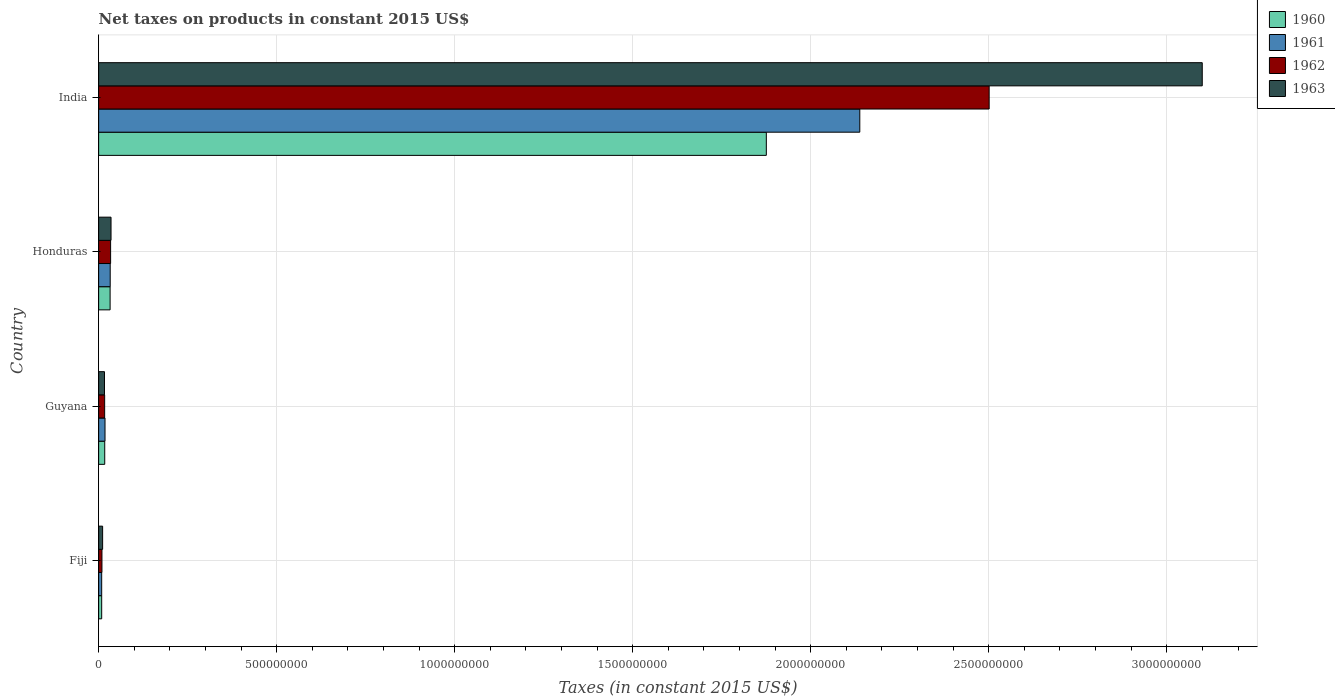How many different coloured bars are there?
Offer a very short reply. 4. How many groups of bars are there?
Ensure brevity in your answer.  4. Are the number of bars per tick equal to the number of legend labels?
Your response must be concise. Yes. How many bars are there on the 1st tick from the top?
Offer a very short reply. 4. What is the label of the 2nd group of bars from the top?
Offer a very short reply. Honduras. What is the net taxes on products in 1961 in Guyana?
Your answer should be very brief. 1.79e+07. Across all countries, what is the maximum net taxes on products in 1962?
Make the answer very short. 2.50e+09. Across all countries, what is the minimum net taxes on products in 1960?
Ensure brevity in your answer.  8.56e+06. In which country was the net taxes on products in 1963 maximum?
Your answer should be very brief. India. In which country was the net taxes on products in 1961 minimum?
Your answer should be very brief. Fiji. What is the total net taxes on products in 1961 in the graph?
Keep it short and to the point. 2.20e+09. What is the difference between the net taxes on products in 1961 in Guyana and that in India?
Ensure brevity in your answer.  -2.12e+09. What is the difference between the net taxes on products in 1962 in India and the net taxes on products in 1960 in Honduras?
Make the answer very short. 2.47e+09. What is the average net taxes on products in 1963 per country?
Give a very brief answer. 7.91e+08. What is the difference between the net taxes on products in 1960 and net taxes on products in 1962 in Fiji?
Offer a very short reply. -7.56e+05. What is the ratio of the net taxes on products in 1963 in Fiji to that in Guyana?
Keep it short and to the point. 0.68. Is the net taxes on products in 1960 in Fiji less than that in Guyana?
Give a very brief answer. Yes. Is the difference between the net taxes on products in 1960 in Fiji and Honduras greater than the difference between the net taxes on products in 1962 in Fiji and Honduras?
Your response must be concise. Yes. What is the difference between the highest and the second highest net taxes on products in 1960?
Provide a succinct answer. 1.84e+09. What is the difference between the highest and the lowest net taxes on products in 1963?
Your response must be concise. 3.09e+09. In how many countries, is the net taxes on products in 1960 greater than the average net taxes on products in 1960 taken over all countries?
Offer a very short reply. 1. Is the sum of the net taxes on products in 1961 in Fiji and India greater than the maximum net taxes on products in 1962 across all countries?
Keep it short and to the point. No. Is it the case that in every country, the sum of the net taxes on products in 1960 and net taxes on products in 1961 is greater than the net taxes on products in 1963?
Your response must be concise. Yes. How many countries are there in the graph?
Keep it short and to the point. 4. What is the difference between two consecutive major ticks on the X-axis?
Keep it short and to the point. 5.00e+08. Where does the legend appear in the graph?
Provide a short and direct response. Top right. How are the legend labels stacked?
Give a very brief answer. Vertical. What is the title of the graph?
Give a very brief answer. Net taxes on products in constant 2015 US$. Does "1977" appear as one of the legend labels in the graph?
Your answer should be compact. No. What is the label or title of the X-axis?
Offer a terse response. Taxes (in constant 2015 US$). What is the label or title of the Y-axis?
Your response must be concise. Country. What is the Taxes (in constant 2015 US$) in 1960 in Fiji?
Make the answer very short. 8.56e+06. What is the Taxes (in constant 2015 US$) of 1961 in Fiji?
Provide a succinct answer. 8.56e+06. What is the Taxes (in constant 2015 US$) in 1962 in Fiji?
Make the answer very short. 9.32e+06. What is the Taxes (in constant 2015 US$) of 1963 in Fiji?
Your answer should be compact. 1.12e+07. What is the Taxes (in constant 2015 US$) in 1960 in Guyana?
Provide a short and direct response. 1.71e+07. What is the Taxes (in constant 2015 US$) in 1961 in Guyana?
Keep it short and to the point. 1.79e+07. What is the Taxes (in constant 2015 US$) in 1962 in Guyana?
Give a very brief answer. 1.69e+07. What is the Taxes (in constant 2015 US$) in 1963 in Guyana?
Ensure brevity in your answer.  1.64e+07. What is the Taxes (in constant 2015 US$) of 1960 in Honduras?
Give a very brief answer. 3.22e+07. What is the Taxes (in constant 2015 US$) of 1961 in Honduras?
Your response must be concise. 3.25e+07. What is the Taxes (in constant 2015 US$) in 1962 in Honduras?
Ensure brevity in your answer.  3.36e+07. What is the Taxes (in constant 2015 US$) in 1963 in Honduras?
Offer a very short reply. 3.48e+07. What is the Taxes (in constant 2015 US$) of 1960 in India?
Make the answer very short. 1.88e+09. What is the Taxes (in constant 2015 US$) in 1961 in India?
Your response must be concise. 2.14e+09. What is the Taxes (in constant 2015 US$) in 1962 in India?
Make the answer very short. 2.50e+09. What is the Taxes (in constant 2015 US$) of 1963 in India?
Your answer should be very brief. 3.10e+09. Across all countries, what is the maximum Taxes (in constant 2015 US$) in 1960?
Provide a succinct answer. 1.88e+09. Across all countries, what is the maximum Taxes (in constant 2015 US$) of 1961?
Your answer should be very brief. 2.14e+09. Across all countries, what is the maximum Taxes (in constant 2015 US$) in 1962?
Make the answer very short. 2.50e+09. Across all countries, what is the maximum Taxes (in constant 2015 US$) in 1963?
Provide a short and direct response. 3.10e+09. Across all countries, what is the minimum Taxes (in constant 2015 US$) in 1960?
Your response must be concise. 8.56e+06. Across all countries, what is the minimum Taxes (in constant 2015 US$) of 1961?
Your answer should be compact. 8.56e+06. Across all countries, what is the minimum Taxes (in constant 2015 US$) of 1962?
Offer a very short reply. 9.32e+06. Across all countries, what is the minimum Taxes (in constant 2015 US$) in 1963?
Your answer should be very brief. 1.12e+07. What is the total Taxes (in constant 2015 US$) of 1960 in the graph?
Offer a very short reply. 1.93e+09. What is the total Taxes (in constant 2015 US$) in 1961 in the graph?
Your answer should be very brief. 2.20e+09. What is the total Taxes (in constant 2015 US$) in 1962 in the graph?
Give a very brief answer. 2.56e+09. What is the total Taxes (in constant 2015 US$) in 1963 in the graph?
Your response must be concise. 3.16e+09. What is the difference between the Taxes (in constant 2015 US$) in 1960 in Fiji and that in Guyana?
Provide a succinct answer. -8.59e+06. What is the difference between the Taxes (in constant 2015 US$) in 1961 in Fiji and that in Guyana?
Provide a succinct answer. -9.34e+06. What is the difference between the Taxes (in constant 2015 US$) of 1962 in Fiji and that in Guyana?
Your answer should be compact. -7.60e+06. What is the difference between the Taxes (in constant 2015 US$) in 1963 in Fiji and that in Guyana?
Provide a short and direct response. -5.24e+06. What is the difference between the Taxes (in constant 2015 US$) in 1960 in Fiji and that in Honduras?
Provide a succinct answer. -2.37e+07. What is the difference between the Taxes (in constant 2015 US$) of 1961 in Fiji and that in Honduras?
Keep it short and to the point. -2.39e+07. What is the difference between the Taxes (in constant 2015 US$) of 1962 in Fiji and that in Honduras?
Keep it short and to the point. -2.43e+07. What is the difference between the Taxes (in constant 2015 US$) in 1963 in Fiji and that in Honduras?
Ensure brevity in your answer.  -2.36e+07. What is the difference between the Taxes (in constant 2015 US$) of 1960 in Fiji and that in India?
Provide a short and direct response. -1.87e+09. What is the difference between the Taxes (in constant 2015 US$) in 1961 in Fiji and that in India?
Offer a terse response. -2.13e+09. What is the difference between the Taxes (in constant 2015 US$) of 1962 in Fiji and that in India?
Your answer should be very brief. -2.49e+09. What is the difference between the Taxes (in constant 2015 US$) in 1963 in Fiji and that in India?
Offer a terse response. -3.09e+09. What is the difference between the Taxes (in constant 2015 US$) of 1960 in Guyana and that in Honduras?
Offer a terse response. -1.51e+07. What is the difference between the Taxes (in constant 2015 US$) of 1961 in Guyana and that in Honduras?
Ensure brevity in your answer.  -1.46e+07. What is the difference between the Taxes (in constant 2015 US$) of 1962 in Guyana and that in Honduras?
Provide a succinct answer. -1.67e+07. What is the difference between the Taxes (in constant 2015 US$) of 1963 in Guyana and that in Honduras?
Give a very brief answer. -1.84e+07. What is the difference between the Taxes (in constant 2015 US$) of 1960 in Guyana and that in India?
Keep it short and to the point. -1.86e+09. What is the difference between the Taxes (in constant 2015 US$) in 1961 in Guyana and that in India?
Offer a terse response. -2.12e+09. What is the difference between the Taxes (in constant 2015 US$) of 1962 in Guyana and that in India?
Keep it short and to the point. -2.48e+09. What is the difference between the Taxes (in constant 2015 US$) in 1963 in Guyana and that in India?
Your answer should be very brief. -3.08e+09. What is the difference between the Taxes (in constant 2015 US$) of 1960 in Honduras and that in India?
Your answer should be compact. -1.84e+09. What is the difference between the Taxes (in constant 2015 US$) in 1961 in Honduras and that in India?
Provide a succinct answer. -2.11e+09. What is the difference between the Taxes (in constant 2015 US$) of 1962 in Honduras and that in India?
Keep it short and to the point. -2.47e+09. What is the difference between the Taxes (in constant 2015 US$) of 1963 in Honduras and that in India?
Your answer should be compact. -3.06e+09. What is the difference between the Taxes (in constant 2015 US$) in 1960 in Fiji and the Taxes (in constant 2015 US$) in 1961 in Guyana?
Your response must be concise. -9.34e+06. What is the difference between the Taxes (in constant 2015 US$) of 1960 in Fiji and the Taxes (in constant 2015 US$) of 1962 in Guyana?
Give a very brief answer. -8.35e+06. What is the difference between the Taxes (in constant 2015 US$) of 1960 in Fiji and the Taxes (in constant 2015 US$) of 1963 in Guyana?
Your response must be concise. -7.89e+06. What is the difference between the Taxes (in constant 2015 US$) of 1961 in Fiji and the Taxes (in constant 2015 US$) of 1962 in Guyana?
Provide a succinct answer. -8.35e+06. What is the difference between the Taxes (in constant 2015 US$) of 1961 in Fiji and the Taxes (in constant 2015 US$) of 1963 in Guyana?
Your response must be concise. -7.89e+06. What is the difference between the Taxes (in constant 2015 US$) of 1962 in Fiji and the Taxes (in constant 2015 US$) of 1963 in Guyana?
Provide a short and direct response. -7.13e+06. What is the difference between the Taxes (in constant 2015 US$) of 1960 in Fiji and the Taxes (in constant 2015 US$) of 1961 in Honduras?
Give a very brief answer. -2.39e+07. What is the difference between the Taxes (in constant 2015 US$) in 1960 in Fiji and the Taxes (in constant 2015 US$) in 1962 in Honduras?
Provide a succinct answer. -2.51e+07. What is the difference between the Taxes (in constant 2015 US$) of 1960 in Fiji and the Taxes (in constant 2015 US$) of 1963 in Honduras?
Offer a very short reply. -2.62e+07. What is the difference between the Taxes (in constant 2015 US$) in 1961 in Fiji and the Taxes (in constant 2015 US$) in 1962 in Honduras?
Your answer should be very brief. -2.51e+07. What is the difference between the Taxes (in constant 2015 US$) of 1961 in Fiji and the Taxes (in constant 2015 US$) of 1963 in Honduras?
Give a very brief answer. -2.62e+07. What is the difference between the Taxes (in constant 2015 US$) of 1962 in Fiji and the Taxes (in constant 2015 US$) of 1963 in Honduras?
Offer a terse response. -2.55e+07. What is the difference between the Taxes (in constant 2015 US$) of 1960 in Fiji and the Taxes (in constant 2015 US$) of 1961 in India?
Ensure brevity in your answer.  -2.13e+09. What is the difference between the Taxes (in constant 2015 US$) in 1960 in Fiji and the Taxes (in constant 2015 US$) in 1962 in India?
Offer a terse response. -2.49e+09. What is the difference between the Taxes (in constant 2015 US$) in 1960 in Fiji and the Taxes (in constant 2015 US$) in 1963 in India?
Your response must be concise. -3.09e+09. What is the difference between the Taxes (in constant 2015 US$) of 1961 in Fiji and the Taxes (in constant 2015 US$) of 1962 in India?
Provide a succinct answer. -2.49e+09. What is the difference between the Taxes (in constant 2015 US$) in 1961 in Fiji and the Taxes (in constant 2015 US$) in 1963 in India?
Make the answer very short. -3.09e+09. What is the difference between the Taxes (in constant 2015 US$) in 1962 in Fiji and the Taxes (in constant 2015 US$) in 1963 in India?
Provide a succinct answer. -3.09e+09. What is the difference between the Taxes (in constant 2015 US$) in 1960 in Guyana and the Taxes (in constant 2015 US$) in 1961 in Honduras?
Your response must be concise. -1.54e+07. What is the difference between the Taxes (in constant 2015 US$) in 1960 in Guyana and the Taxes (in constant 2015 US$) in 1962 in Honduras?
Keep it short and to the point. -1.65e+07. What is the difference between the Taxes (in constant 2015 US$) in 1960 in Guyana and the Taxes (in constant 2015 US$) in 1963 in Honduras?
Provide a succinct answer. -1.77e+07. What is the difference between the Taxes (in constant 2015 US$) of 1961 in Guyana and the Taxes (in constant 2015 US$) of 1962 in Honduras?
Your answer should be very brief. -1.57e+07. What is the difference between the Taxes (in constant 2015 US$) of 1961 in Guyana and the Taxes (in constant 2015 US$) of 1963 in Honduras?
Keep it short and to the point. -1.69e+07. What is the difference between the Taxes (in constant 2015 US$) of 1962 in Guyana and the Taxes (in constant 2015 US$) of 1963 in Honduras?
Your answer should be compact. -1.79e+07. What is the difference between the Taxes (in constant 2015 US$) in 1960 in Guyana and the Taxes (in constant 2015 US$) in 1961 in India?
Make the answer very short. -2.12e+09. What is the difference between the Taxes (in constant 2015 US$) of 1960 in Guyana and the Taxes (in constant 2015 US$) of 1962 in India?
Give a very brief answer. -2.48e+09. What is the difference between the Taxes (in constant 2015 US$) in 1960 in Guyana and the Taxes (in constant 2015 US$) in 1963 in India?
Give a very brief answer. -3.08e+09. What is the difference between the Taxes (in constant 2015 US$) in 1961 in Guyana and the Taxes (in constant 2015 US$) in 1962 in India?
Your answer should be very brief. -2.48e+09. What is the difference between the Taxes (in constant 2015 US$) of 1961 in Guyana and the Taxes (in constant 2015 US$) of 1963 in India?
Provide a short and direct response. -3.08e+09. What is the difference between the Taxes (in constant 2015 US$) in 1962 in Guyana and the Taxes (in constant 2015 US$) in 1963 in India?
Offer a terse response. -3.08e+09. What is the difference between the Taxes (in constant 2015 US$) in 1960 in Honduras and the Taxes (in constant 2015 US$) in 1961 in India?
Offer a very short reply. -2.11e+09. What is the difference between the Taxes (in constant 2015 US$) of 1960 in Honduras and the Taxes (in constant 2015 US$) of 1962 in India?
Ensure brevity in your answer.  -2.47e+09. What is the difference between the Taxes (in constant 2015 US$) of 1960 in Honduras and the Taxes (in constant 2015 US$) of 1963 in India?
Keep it short and to the point. -3.07e+09. What is the difference between the Taxes (in constant 2015 US$) of 1961 in Honduras and the Taxes (in constant 2015 US$) of 1962 in India?
Your answer should be very brief. -2.47e+09. What is the difference between the Taxes (in constant 2015 US$) of 1961 in Honduras and the Taxes (in constant 2015 US$) of 1963 in India?
Keep it short and to the point. -3.07e+09. What is the difference between the Taxes (in constant 2015 US$) in 1962 in Honduras and the Taxes (in constant 2015 US$) in 1963 in India?
Your answer should be compact. -3.07e+09. What is the average Taxes (in constant 2015 US$) in 1960 per country?
Your answer should be very brief. 4.83e+08. What is the average Taxes (in constant 2015 US$) in 1961 per country?
Your answer should be very brief. 5.49e+08. What is the average Taxes (in constant 2015 US$) in 1962 per country?
Ensure brevity in your answer.  6.40e+08. What is the average Taxes (in constant 2015 US$) in 1963 per country?
Ensure brevity in your answer.  7.91e+08. What is the difference between the Taxes (in constant 2015 US$) in 1960 and Taxes (in constant 2015 US$) in 1961 in Fiji?
Keep it short and to the point. 0. What is the difference between the Taxes (in constant 2015 US$) of 1960 and Taxes (in constant 2015 US$) of 1962 in Fiji?
Your answer should be compact. -7.56e+05. What is the difference between the Taxes (in constant 2015 US$) of 1960 and Taxes (in constant 2015 US$) of 1963 in Fiji?
Your answer should be compact. -2.64e+06. What is the difference between the Taxes (in constant 2015 US$) of 1961 and Taxes (in constant 2015 US$) of 1962 in Fiji?
Keep it short and to the point. -7.56e+05. What is the difference between the Taxes (in constant 2015 US$) of 1961 and Taxes (in constant 2015 US$) of 1963 in Fiji?
Your answer should be compact. -2.64e+06. What is the difference between the Taxes (in constant 2015 US$) in 1962 and Taxes (in constant 2015 US$) in 1963 in Fiji?
Offer a terse response. -1.89e+06. What is the difference between the Taxes (in constant 2015 US$) in 1960 and Taxes (in constant 2015 US$) in 1961 in Guyana?
Give a very brief answer. -7.58e+05. What is the difference between the Taxes (in constant 2015 US$) of 1960 and Taxes (in constant 2015 US$) of 1962 in Guyana?
Provide a succinct answer. 2.33e+05. What is the difference between the Taxes (in constant 2015 US$) in 1960 and Taxes (in constant 2015 US$) in 1963 in Guyana?
Your answer should be compact. 7.00e+05. What is the difference between the Taxes (in constant 2015 US$) of 1961 and Taxes (in constant 2015 US$) of 1962 in Guyana?
Provide a short and direct response. 9.92e+05. What is the difference between the Taxes (in constant 2015 US$) of 1961 and Taxes (in constant 2015 US$) of 1963 in Guyana?
Provide a short and direct response. 1.46e+06. What is the difference between the Taxes (in constant 2015 US$) in 1962 and Taxes (in constant 2015 US$) in 1963 in Guyana?
Your response must be concise. 4.67e+05. What is the difference between the Taxes (in constant 2015 US$) in 1960 and Taxes (in constant 2015 US$) in 1961 in Honduras?
Provide a short and direct response. -2.50e+05. What is the difference between the Taxes (in constant 2015 US$) of 1960 and Taxes (in constant 2015 US$) of 1962 in Honduras?
Provide a short and direct response. -1.40e+06. What is the difference between the Taxes (in constant 2015 US$) of 1960 and Taxes (in constant 2015 US$) of 1963 in Honduras?
Provide a short and direct response. -2.55e+06. What is the difference between the Taxes (in constant 2015 US$) in 1961 and Taxes (in constant 2015 US$) in 1962 in Honduras?
Your answer should be very brief. -1.15e+06. What is the difference between the Taxes (in constant 2015 US$) in 1961 and Taxes (in constant 2015 US$) in 1963 in Honduras?
Keep it short and to the point. -2.30e+06. What is the difference between the Taxes (in constant 2015 US$) of 1962 and Taxes (in constant 2015 US$) of 1963 in Honduras?
Give a very brief answer. -1.15e+06. What is the difference between the Taxes (in constant 2015 US$) in 1960 and Taxes (in constant 2015 US$) in 1961 in India?
Your answer should be compact. -2.63e+08. What is the difference between the Taxes (in constant 2015 US$) in 1960 and Taxes (in constant 2015 US$) in 1962 in India?
Give a very brief answer. -6.26e+08. What is the difference between the Taxes (in constant 2015 US$) of 1960 and Taxes (in constant 2015 US$) of 1963 in India?
Your answer should be compact. -1.22e+09. What is the difference between the Taxes (in constant 2015 US$) of 1961 and Taxes (in constant 2015 US$) of 1962 in India?
Offer a terse response. -3.63e+08. What is the difference between the Taxes (in constant 2015 US$) in 1961 and Taxes (in constant 2015 US$) in 1963 in India?
Provide a short and direct response. -9.62e+08. What is the difference between the Taxes (in constant 2015 US$) of 1962 and Taxes (in constant 2015 US$) of 1963 in India?
Give a very brief answer. -5.99e+08. What is the ratio of the Taxes (in constant 2015 US$) of 1960 in Fiji to that in Guyana?
Your response must be concise. 0.5. What is the ratio of the Taxes (in constant 2015 US$) of 1961 in Fiji to that in Guyana?
Your answer should be very brief. 0.48. What is the ratio of the Taxes (in constant 2015 US$) of 1962 in Fiji to that in Guyana?
Offer a very short reply. 0.55. What is the ratio of the Taxes (in constant 2015 US$) in 1963 in Fiji to that in Guyana?
Offer a very short reply. 0.68. What is the ratio of the Taxes (in constant 2015 US$) of 1960 in Fiji to that in Honduras?
Make the answer very short. 0.27. What is the ratio of the Taxes (in constant 2015 US$) of 1961 in Fiji to that in Honduras?
Keep it short and to the point. 0.26. What is the ratio of the Taxes (in constant 2015 US$) in 1962 in Fiji to that in Honduras?
Offer a very short reply. 0.28. What is the ratio of the Taxes (in constant 2015 US$) of 1963 in Fiji to that in Honduras?
Offer a terse response. 0.32. What is the ratio of the Taxes (in constant 2015 US$) of 1960 in Fiji to that in India?
Your answer should be compact. 0. What is the ratio of the Taxes (in constant 2015 US$) in 1961 in Fiji to that in India?
Offer a terse response. 0. What is the ratio of the Taxes (in constant 2015 US$) in 1962 in Fiji to that in India?
Give a very brief answer. 0. What is the ratio of the Taxes (in constant 2015 US$) of 1963 in Fiji to that in India?
Offer a terse response. 0. What is the ratio of the Taxes (in constant 2015 US$) of 1960 in Guyana to that in Honduras?
Your answer should be compact. 0.53. What is the ratio of the Taxes (in constant 2015 US$) of 1961 in Guyana to that in Honduras?
Your answer should be very brief. 0.55. What is the ratio of the Taxes (in constant 2015 US$) in 1962 in Guyana to that in Honduras?
Your response must be concise. 0.5. What is the ratio of the Taxes (in constant 2015 US$) in 1963 in Guyana to that in Honduras?
Provide a succinct answer. 0.47. What is the ratio of the Taxes (in constant 2015 US$) in 1960 in Guyana to that in India?
Provide a succinct answer. 0.01. What is the ratio of the Taxes (in constant 2015 US$) of 1961 in Guyana to that in India?
Give a very brief answer. 0.01. What is the ratio of the Taxes (in constant 2015 US$) of 1962 in Guyana to that in India?
Provide a succinct answer. 0.01. What is the ratio of the Taxes (in constant 2015 US$) of 1963 in Guyana to that in India?
Provide a short and direct response. 0.01. What is the ratio of the Taxes (in constant 2015 US$) of 1960 in Honduras to that in India?
Ensure brevity in your answer.  0.02. What is the ratio of the Taxes (in constant 2015 US$) in 1961 in Honduras to that in India?
Make the answer very short. 0.02. What is the ratio of the Taxes (in constant 2015 US$) in 1962 in Honduras to that in India?
Offer a terse response. 0.01. What is the ratio of the Taxes (in constant 2015 US$) of 1963 in Honduras to that in India?
Provide a succinct answer. 0.01. What is the difference between the highest and the second highest Taxes (in constant 2015 US$) in 1960?
Offer a very short reply. 1.84e+09. What is the difference between the highest and the second highest Taxes (in constant 2015 US$) of 1961?
Offer a terse response. 2.11e+09. What is the difference between the highest and the second highest Taxes (in constant 2015 US$) in 1962?
Provide a short and direct response. 2.47e+09. What is the difference between the highest and the second highest Taxes (in constant 2015 US$) of 1963?
Your answer should be compact. 3.06e+09. What is the difference between the highest and the lowest Taxes (in constant 2015 US$) in 1960?
Your answer should be very brief. 1.87e+09. What is the difference between the highest and the lowest Taxes (in constant 2015 US$) in 1961?
Your response must be concise. 2.13e+09. What is the difference between the highest and the lowest Taxes (in constant 2015 US$) in 1962?
Provide a succinct answer. 2.49e+09. What is the difference between the highest and the lowest Taxes (in constant 2015 US$) in 1963?
Provide a succinct answer. 3.09e+09. 